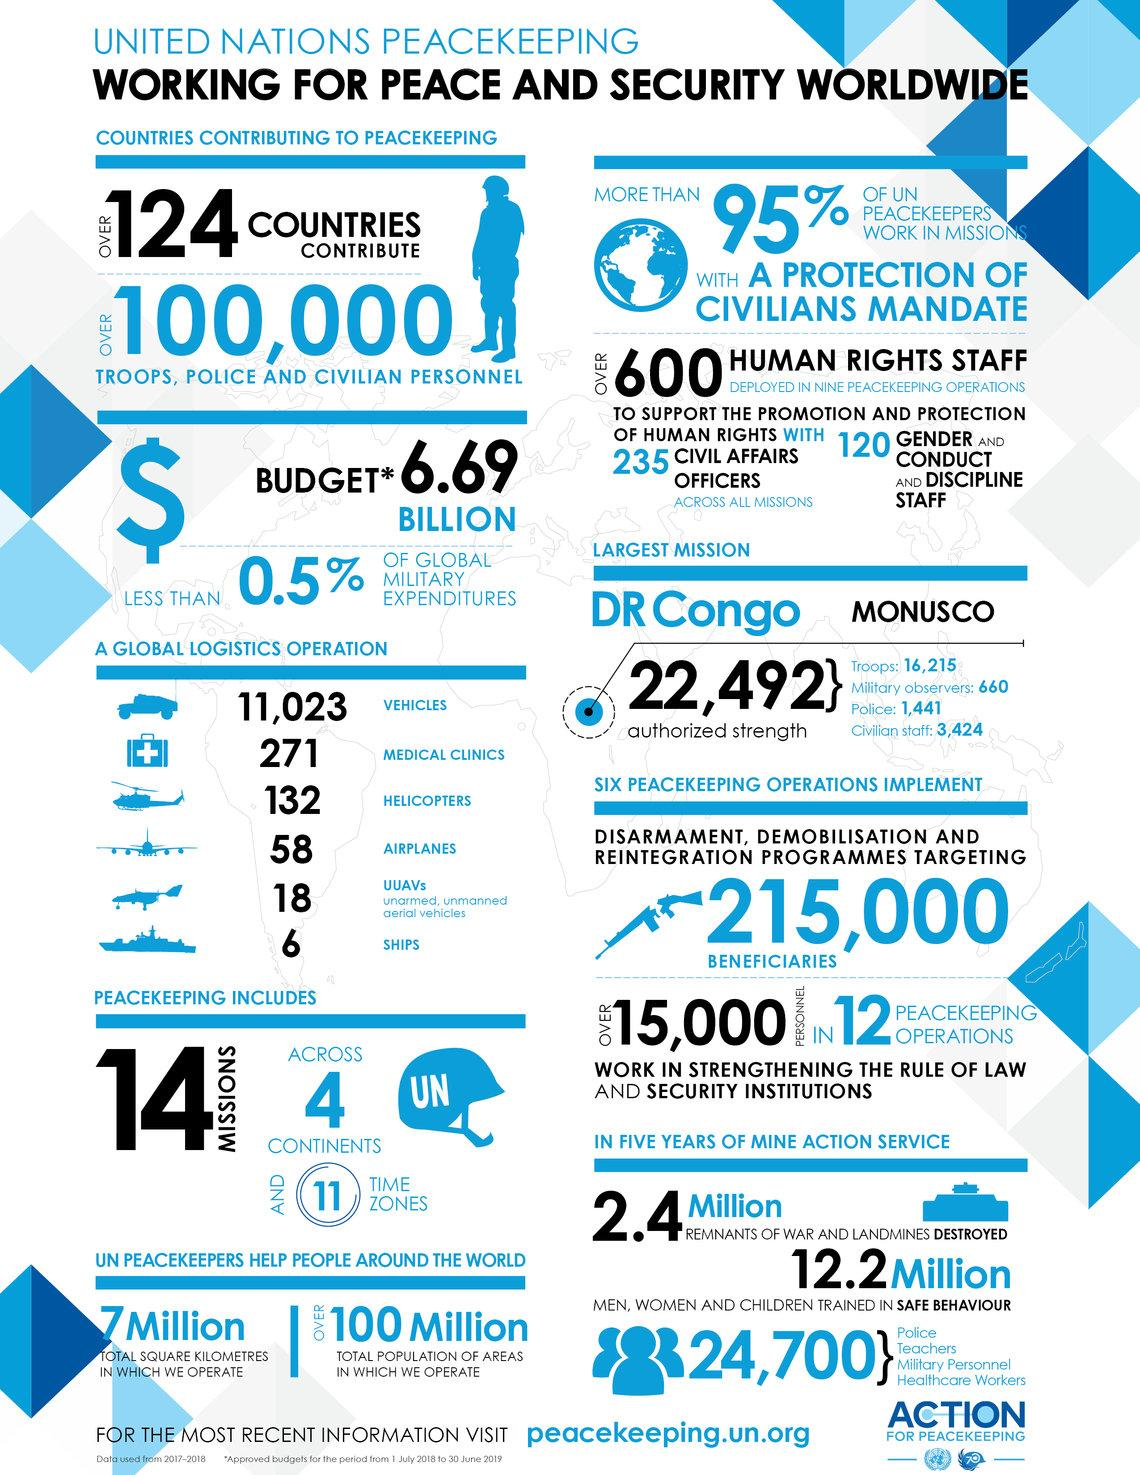Draw attention to some important aspects in this diagram. The total population of areas where United Nations peacekeepers operate is over 100 million. As of 2021, the total number of forces deployed for the United Nations Mission in the Congo (MONUSCO) is 22,492. The United Nations Mission in the Congo (MONUSCO) has deployed a total of 3,424 civilian staff members in support of its operations. A total of 14 UN peacekeeping missions have been deployed across different continents. The UN peacekeeping mission with the largest deployment is MONUSCO, which is operating in the Democratic Republic of the Congo. 